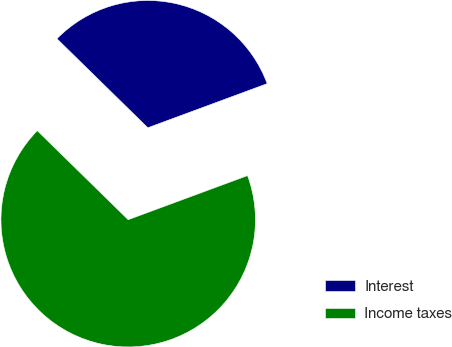<chart> <loc_0><loc_0><loc_500><loc_500><pie_chart><fcel>Interest<fcel>Income taxes<nl><fcel>32.03%<fcel>67.97%<nl></chart> 